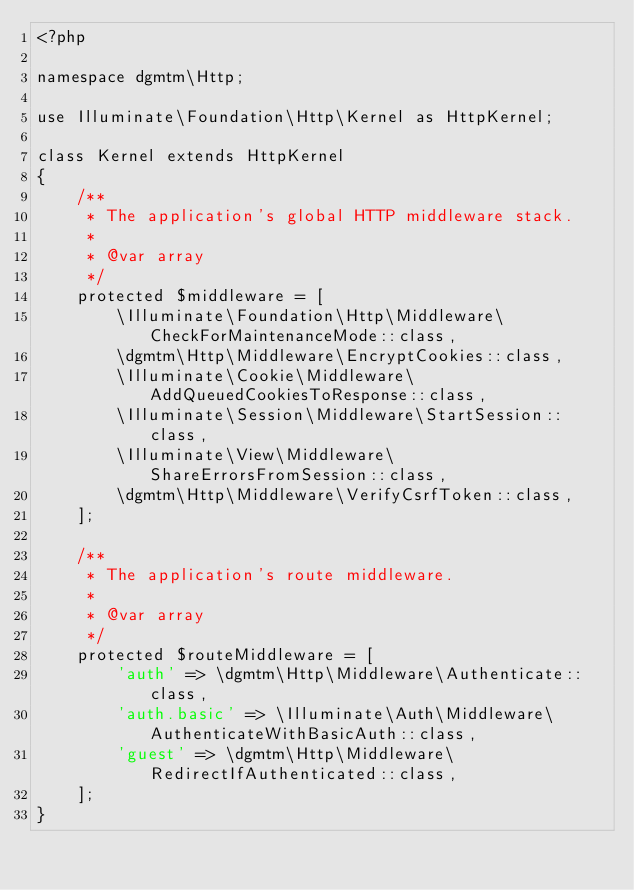Convert code to text. <code><loc_0><loc_0><loc_500><loc_500><_PHP_><?php

namespace dgmtm\Http;

use Illuminate\Foundation\Http\Kernel as HttpKernel;

class Kernel extends HttpKernel
{
    /**
     * The application's global HTTP middleware stack.
     *
     * @var array
     */
    protected $middleware = [
        \Illuminate\Foundation\Http\Middleware\CheckForMaintenanceMode::class,
        \dgmtm\Http\Middleware\EncryptCookies::class,
        \Illuminate\Cookie\Middleware\AddQueuedCookiesToResponse::class,
        \Illuminate\Session\Middleware\StartSession::class,
        \Illuminate\View\Middleware\ShareErrorsFromSession::class,
        \dgmtm\Http\Middleware\VerifyCsrfToken::class,
    ];

    /**
     * The application's route middleware.
     *
     * @var array
     */
    protected $routeMiddleware = [
        'auth' => \dgmtm\Http\Middleware\Authenticate::class,
        'auth.basic' => \Illuminate\Auth\Middleware\AuthenticateWithBasicAuth::class,
        'guest' => \dgmtm\Http\Middleware\RedirectIfAuthenticated::class,
    ];
}
</code> 